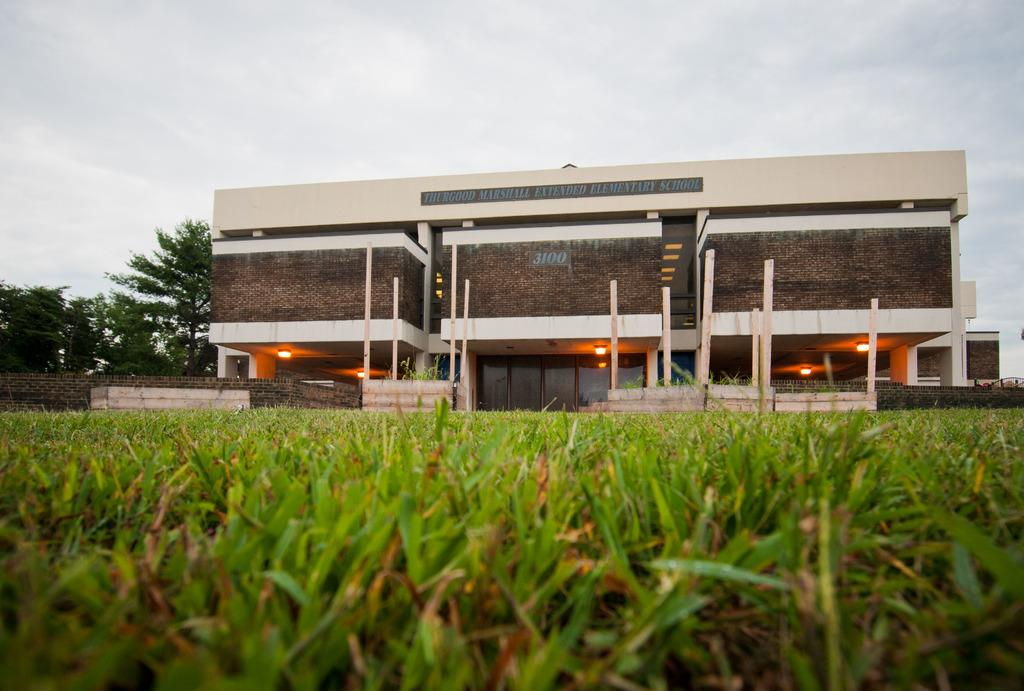What type of vegetation is in the foreground of the image? There is grass in the foreground of the image. What structures can be seen in the background of the image? There is a house and a wall in the background of the image. What other natural elements are visible in the background of the image? There are trees and the sky visible in the background of the image. How many farmers are present in the image? There are no farmers present in the image. What type of crowd can be seen gathering around the trees in the image? There is no crowd present in the image; it only features grass, a house, a wall, trees, and the sky. 